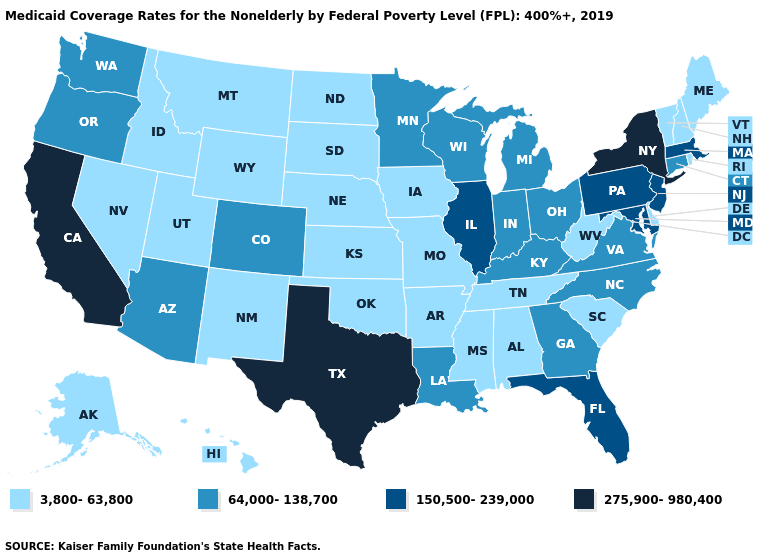Does Michigan have the same value as West Virginia?
Keep it brief. No. Which states hav the highest value in the West?
Answer briefly. California. What is the highest value in the USA?
Give a very brief answer. 275,900-980,400. What is the value of Arkansas?
Short answer required. 3,800-63,800. Which states hav the highest value in the West?
Be succinct. California. Which states have the lowest value in the Northeast?
Quick response, please. Maine, New Hampshire, Rhode Island, Vermont. What is the lowest value in the USA?
Give a very brief answer. 3,800-63,800. Does Michigan have the same value as Louisiana?
Be succinct. Yes. Which states have the lowest value in the USA?
Give a very brief answer. Alabama, Alaska, Arkansas, Delaware, Hawaii, Idaho, Iowa, Kansas, Maine, Mississippi, Missouri, Montana, Nebraska, Nevada, New Hampshire, New Mexico, North Dakota, Oklahoma, Rhode Island, South Carolina, South Dakota, Tennessee, Utah, Vermont, West Virginia, Wyoming. What is the value of Alabama?
Short answer required. 3,800-63,800. Name the states that have a value in the range 150,500-239,000?
Concise answer only. Florida, Illinois, Maryland, Massachusetts, New Jersey, Pennsylvania. What is the value of New Mexico?
Quick response, please. 3,800-63,800. Does Illinois have a lower value than Texas?
Give a very brief answer. Yes. Does the first symbol in the legend represent the smallest category?
Concise answer only. Yes. Is the legend a continuous bar?
Give a very brief answer. No. 